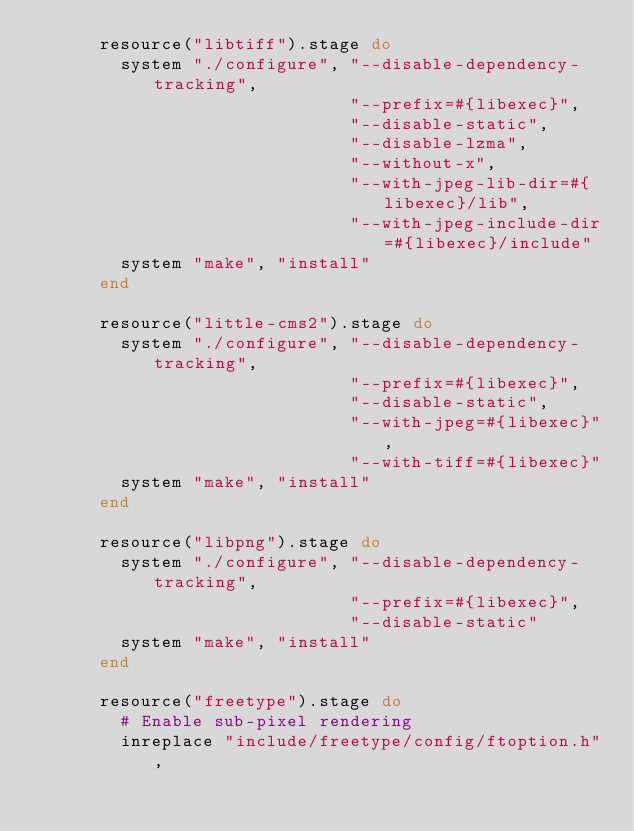<code> <loc_0><loc_0><loc_500><loc_500><_Ruby_>      resource("libtiff").stage do
        system "./configure", "--disable-dependency-tracking",
                              "--prefix=#{libexec}",
                              "--disable-static",
                              "--disable-lzma",
                              "--without-x",
                              "--with-jpeg-lib-dir=#{libexec}/lib",
                              "--with-jpeg-include-dir=#{libexec}/include"
        system "make", "install"
      end

      resource("little-cms2").stage do
        system "./configure", "--disable-dependency-tracking",
                              "--prefix=#{libexec}",
                              "--disable-static",
                              "--with-jpeg=#{libexec}",
                              "--with-tiff=#{libexec}"
        system "make", "install"
      end

      resource("libpng").stage do
        system "./configure", "--disable-dependency-tracking",
                              "--prefix=#{libexec}",
                              "--disable-static"
        system "make", "install"
      end

      resource("freetype").stage do
        # Enable sub-pixel rendering
        inreplace "include/freetype/config/ftoption.h",</code> 